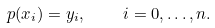<formula> <loc_0><loc_0><loc_500><loc_500>p ( x _ { i } ) = y _ { i } , \quad i = 0 , \dots , n .</formula> 